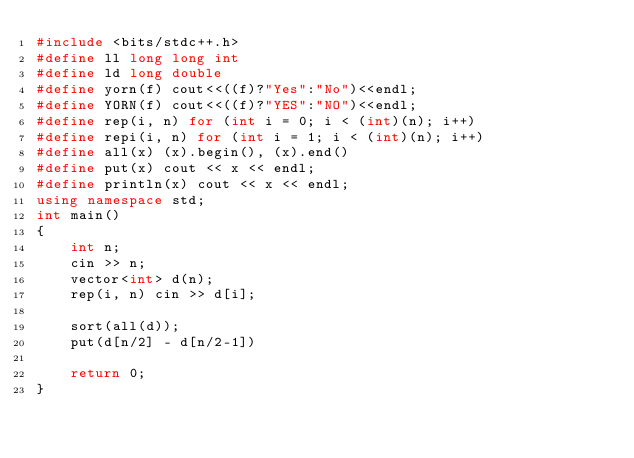<code> <loc_0><loc_0><loc_500><loc_500><_C++_>#include <bits/stdc++.h>
#define ll long long int
#define ld long double
#define yorn(f) cout<<((f)?"Yes":"No")<<endl;
#define YORN(f) cout<<((f)?"YES":"NO")<<endl;
#define rep(i, n) for (int i = 0; i < (int)(n); i++)
#define repi(i, n) for (int i = 1; i < (int)(n); i++)
#define all(x) (x).begin(), (x).end()
#define put(x) cout << x << endl;
#define println(x) cout << x << endl;
using namespace std;
int main()
{
    int n;
    cin >> n;
    vector<int> d(n);
    rep(i, n) cin >> d[i];

    sort(all(d));
    put(d[n/2] - d[n/2-1])

    return 0;
}</code> 